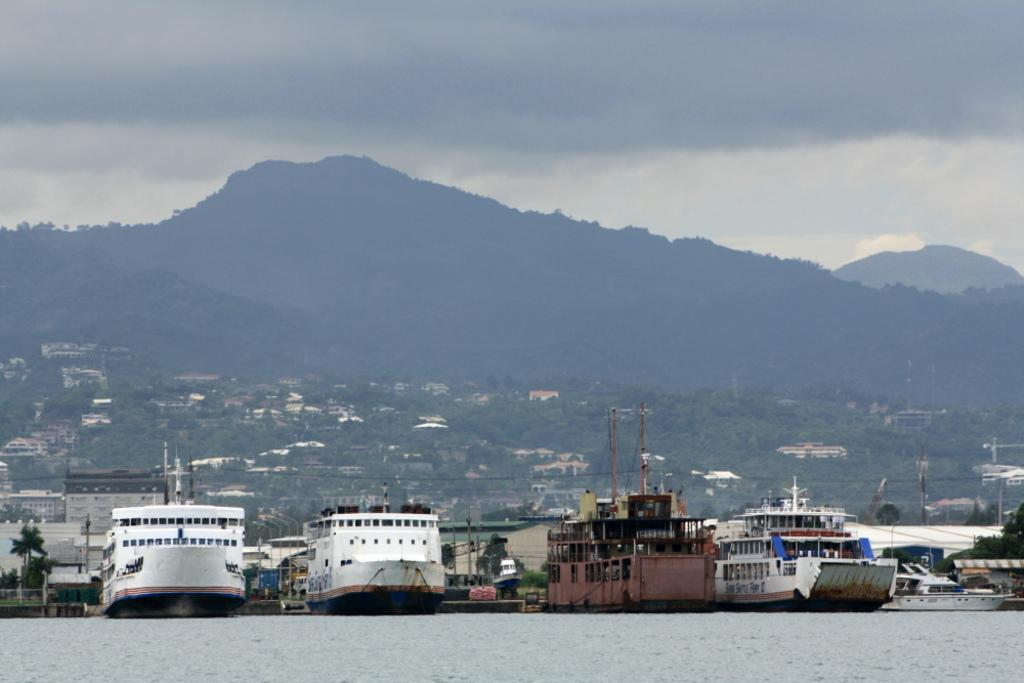What is floating on the water in the image? There are ships floating on the water in the image. What can be seen in the background of the image? There are houses, trees, hills, and a cloudy sky in the background of the image. Can you see any goldfish swimming in the water near the ships? There are no goldfish visible in the image; it features ships floating on water with a background of houses, trees, hills, and a cloudy sky. 